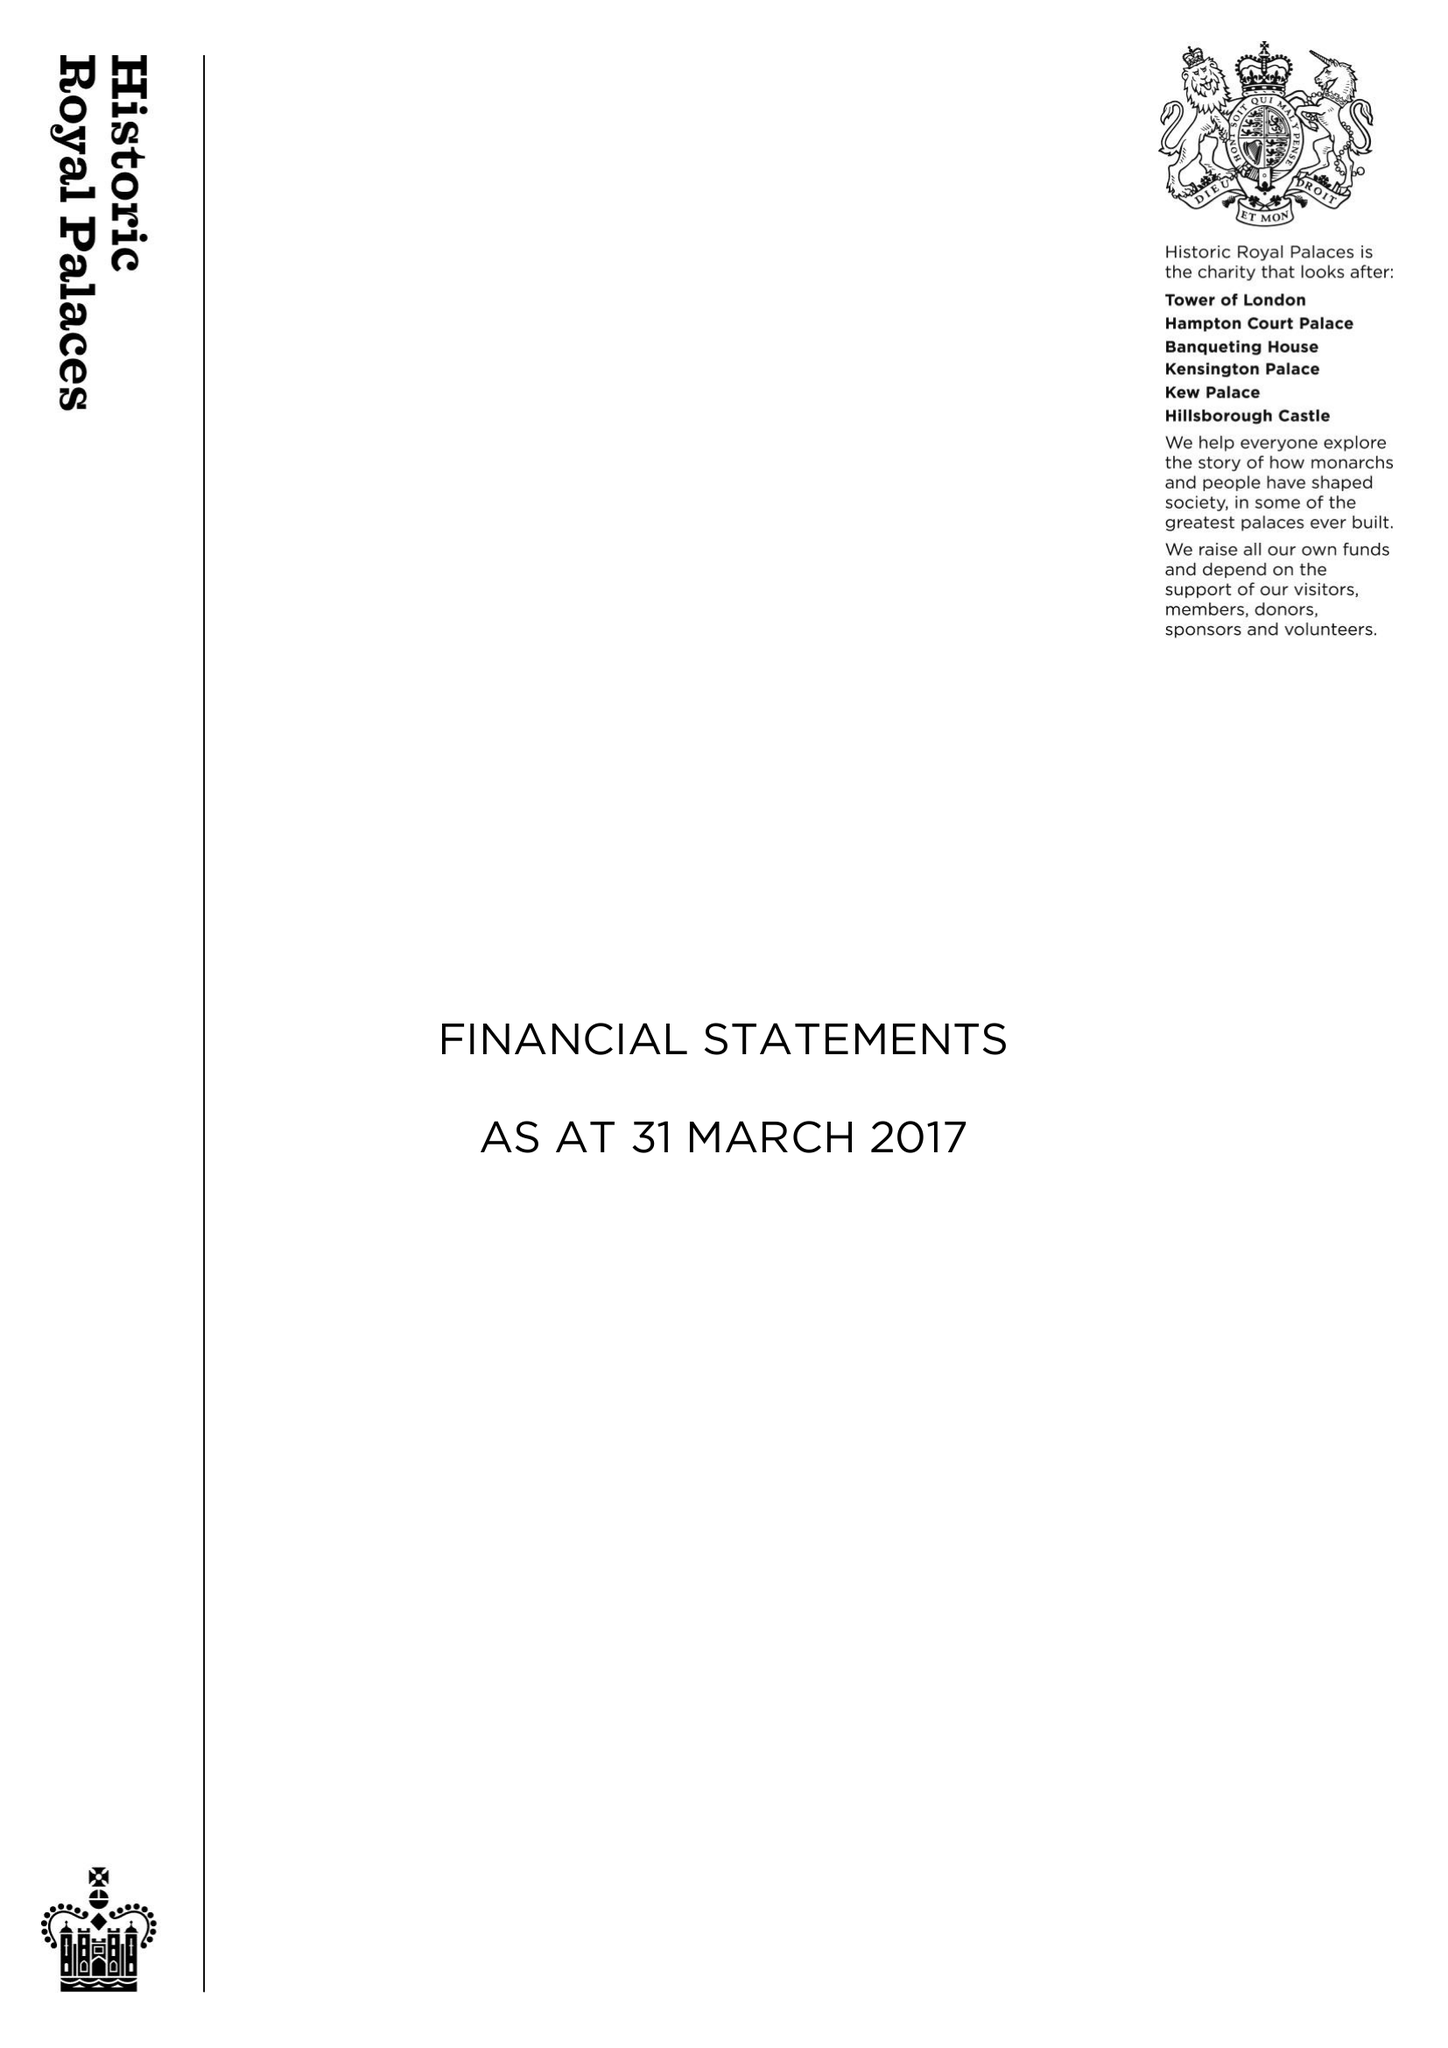What is the value for the report_date?
Answer the question using a single word or phrase. 2017-03-31 